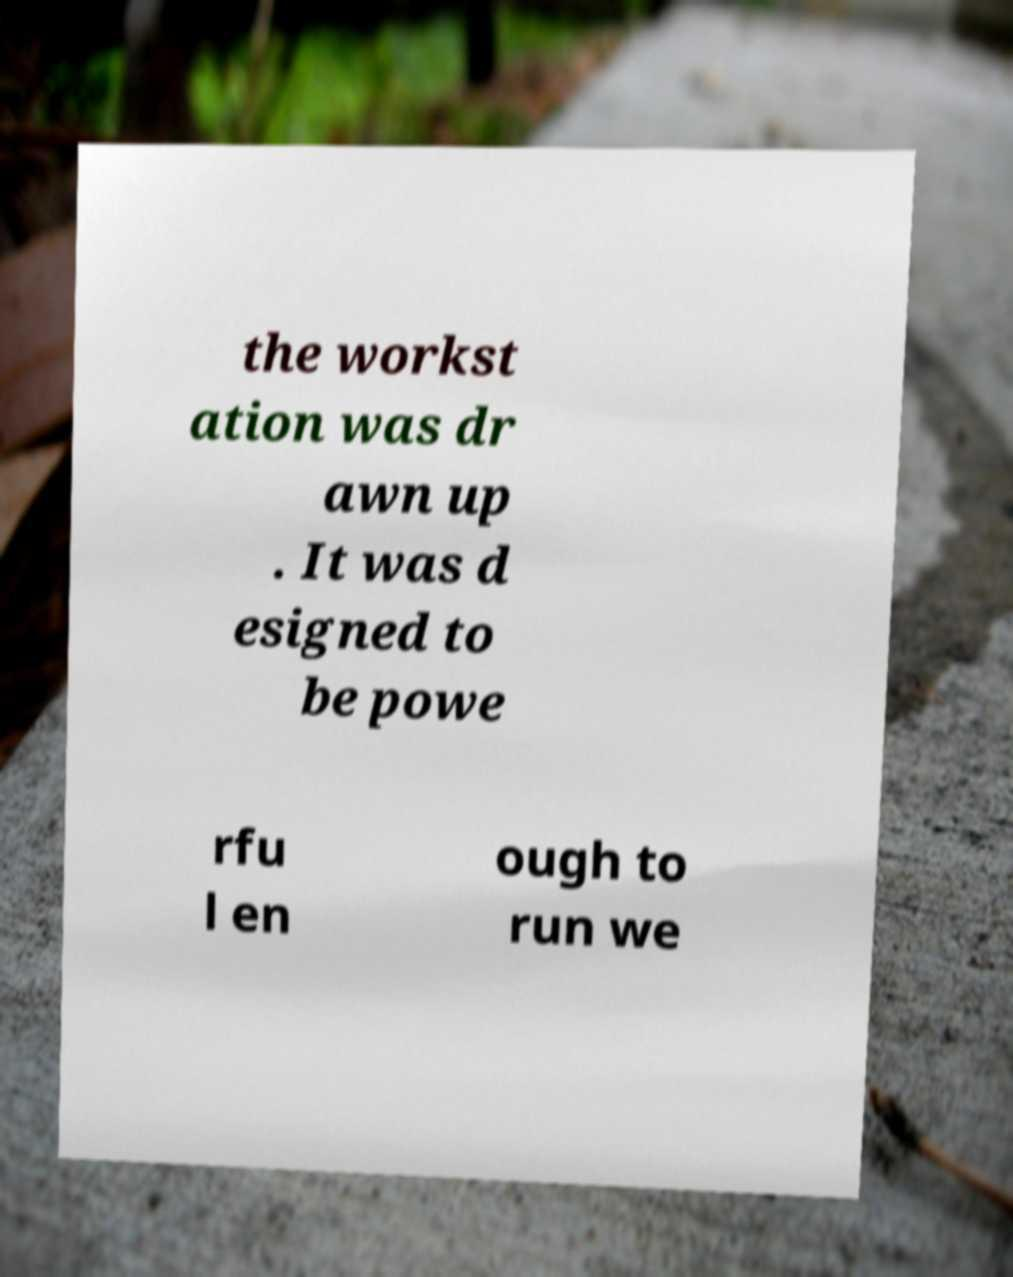Please read and relay the text visible in this image. What does it say? the workst ation was dr awn up . It was d esigned to be powe rfu l en ough to run we 